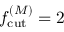<formula> <loc_0><loc_0><loc_500><loc_500>{ f _ { c u t } ^ { ( M ) } } = 2</formula> 